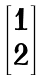<formula> <loc_0><loc_0><loc_500><loc_500>\begin{bmatrix} { 1 } \\ { 2 } \end{bmatrix}</formula> 